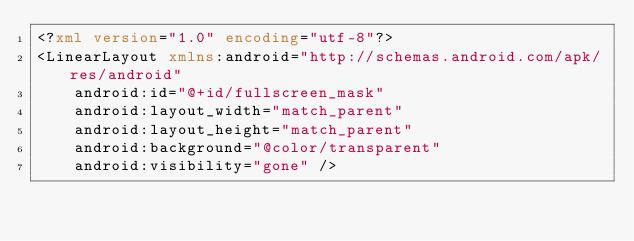Convert code to text. <code><loc_0><loc_0><loc_500><loc_500><_XML_><?xml version="1.0" encoding="utf-8"?>
<LinearLayout xmlns:android="http://schemas.android.com/apk/res/android"
    android:id="@+id/fullscreen_mask"
    android:layout_width="match_parent"
    android:layout_height="match_parent"
    android:background="@color/transparent"
    android:visibility="gone" />
</code> 